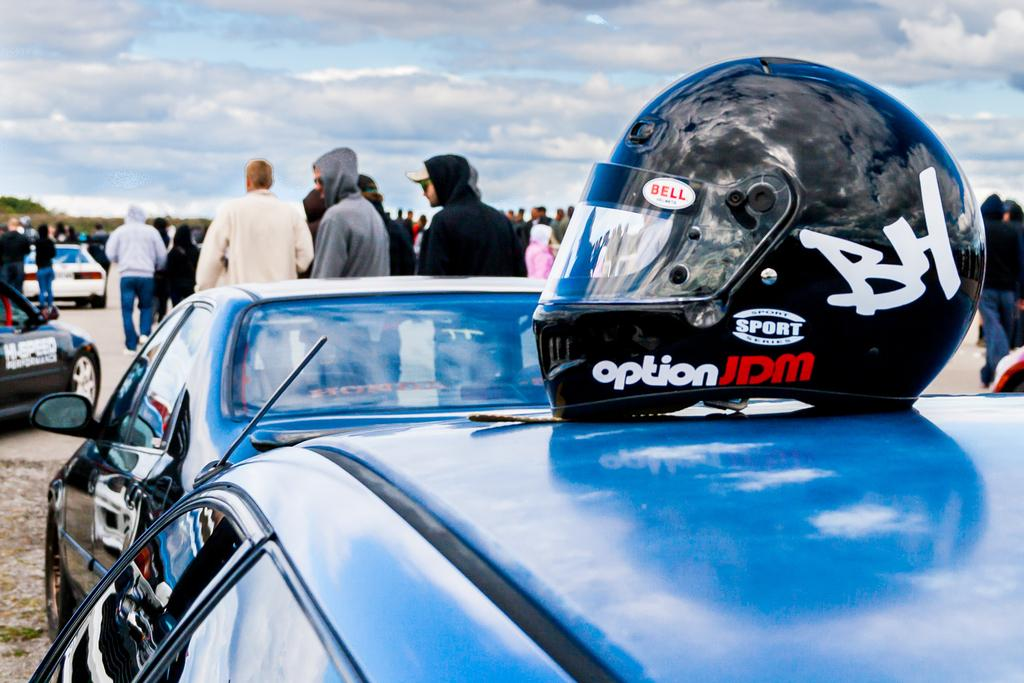What is the main subject of the image? There is a vehicle in the image. What can be seen on the vehicle? There is a helmet on the vehicle. What can be seen in the background of the image? There are vehicles, people standing on the road, trees, and clouds in the sky in the background. What type of hammer is being used by the friend in the image? There is no hammer or friend present in the image. What is the value of the vehicle in the image? The value of the vehicle cannot be determined from the image alone. 